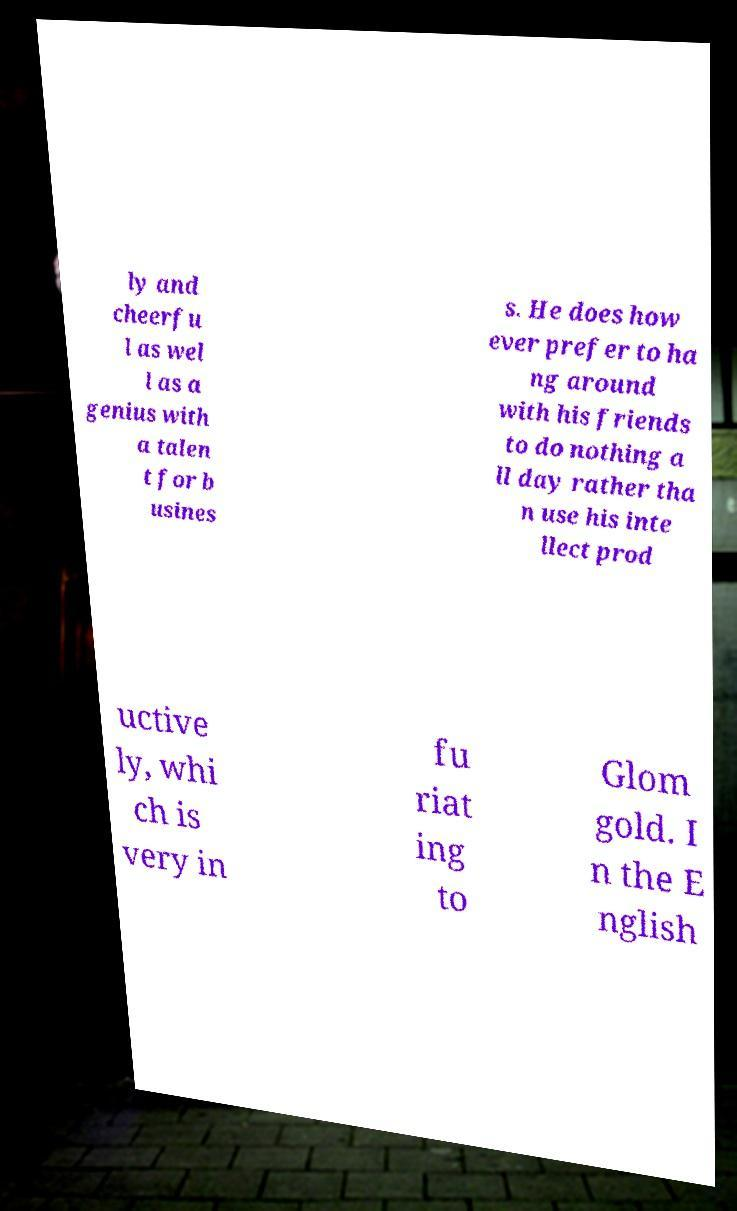There's text embedded in this image that I need extracted. Can you transcribe it verbatim? ly and cheerfu l as wel l as a genius with a talen t for b usines s. He does how ever prefer to ha ng around with his friends to do nothing a ll day rather tha n use his inte llect prod uctive ly, whi ch is very in fu riat ing to Glom gold. I n the E nglish 